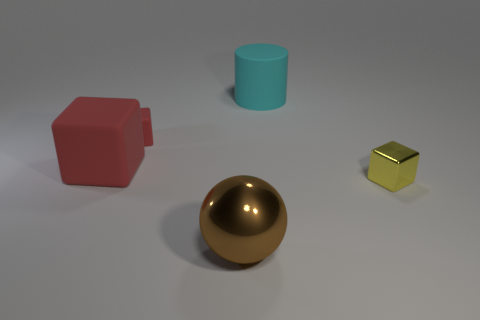Subtract all yellow blocks. How many blocks are left? 2 Add 1 gray rubber things. How many objects exist? 6 Subtract 2 cubes. How many cubes are left? 1 Add 2 cylinders. How many cylinders are left? 3 Add 3 tiny yellow blocks. How many tiny yellow blocks exist? 4 Subtract all red blocks. How many blocks are left? 1 Subtract 1 cyan cylinders. How many objects are left? 4 Subtract all blocks. How many objects are left? 2 Subtract all cyan spheres. Subtract all yellow cylinders. How many spheres are left? 1 Subtract all red spheres. How many brown cylinders are left? 0 